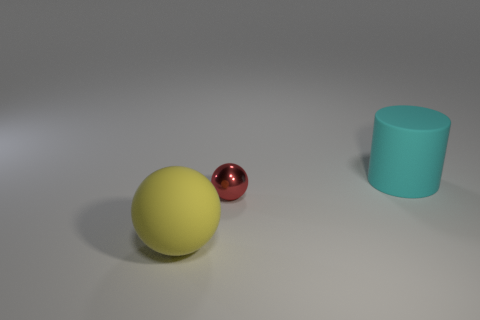Add 1 yellow things. How many objects exist? 4 Subtract all cylinders. How many objects are left? 2 Add 3 tiny gray matte blocks. How many tiny gray matte blocks exist? 3 Subtract 0 purple cylinders. How many objects are left? 3 Subtract all small purple metal cubes. Subtract all metallic balls. How many objects are left? 2 Add 2 red spheres. How many red spheres are left? 3 